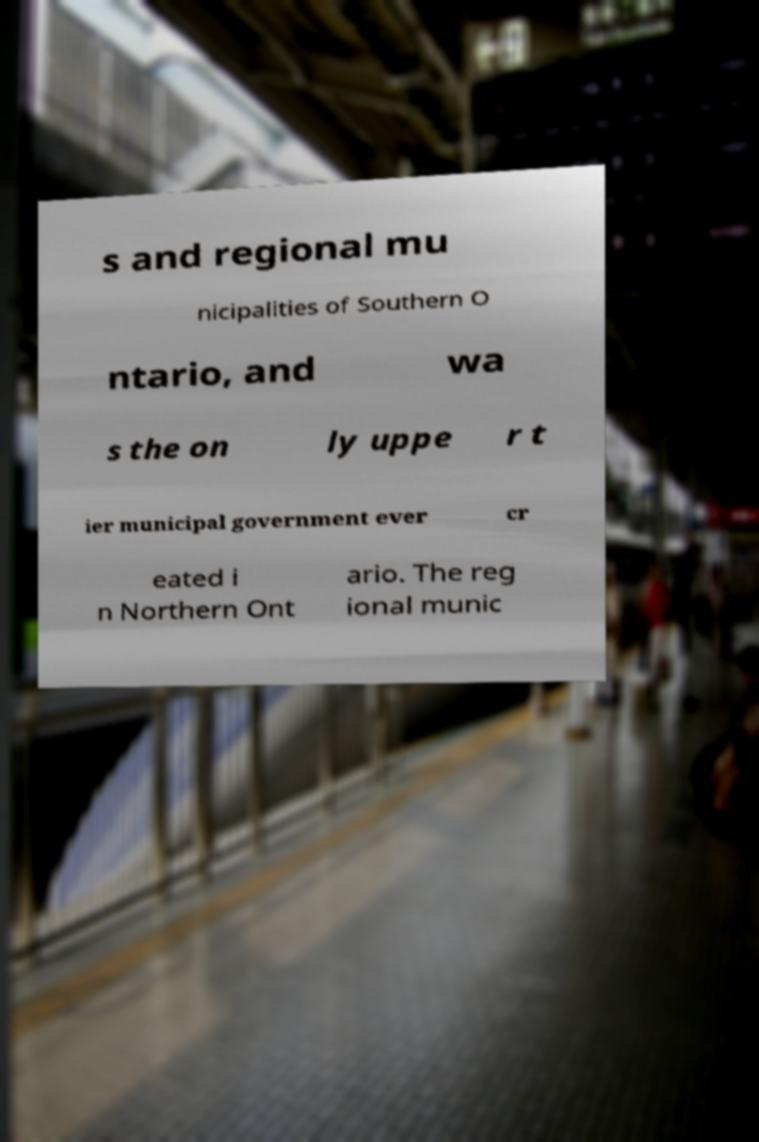Please identify and transcribe the text found in this image. s and regional mu nicipalities of Southern O ntario, and wa s the on ly uppe r t ier municipal government ever cr eated i n Northern Ont ario. The reg ional munic 